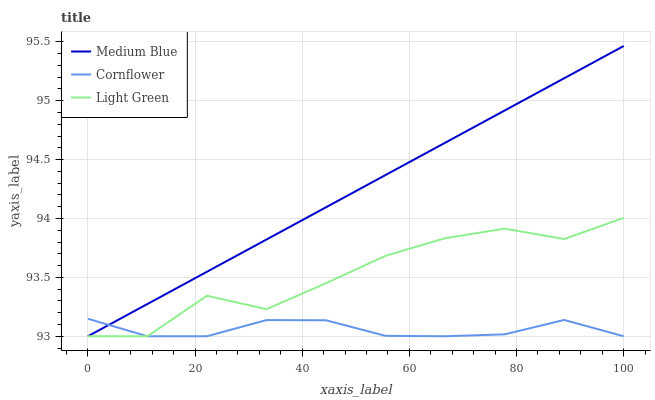Does Light Green have the minimum area under the curve?
Answer yes or no. No. Does Light Green have the maximum area under the curve?
Answer yes or no. No. Is Light Green the smoothest?
Answer yes or no. No. Is Medium Blue the roughest?
Answer yes or no. No. Does Light Green have the highest value?
Answer yes or no. No. 